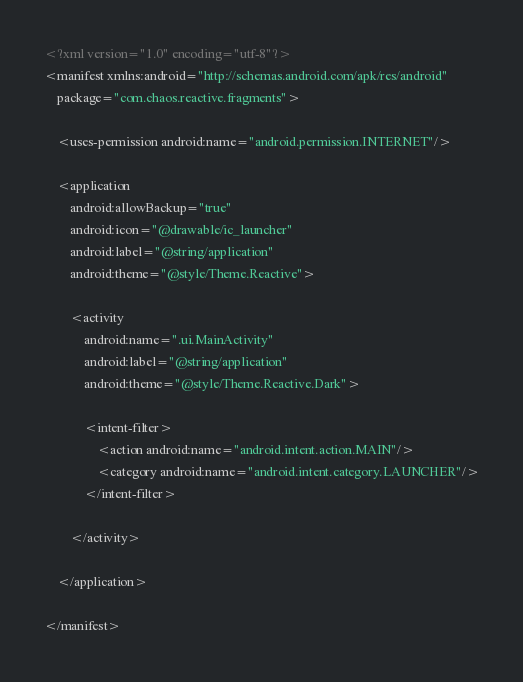<code> <loc_0><loc_0><loc_500><loc_500><_XML_><?xml version="1.0" encoding="utf-8"?>
<manifest xmlns:android="http://schemas.android.com/apk/res/android"
    package="com.chaos.reactive.fragments">

    <uses-permission android:name="android.permission.INTERNET"/>

    <application
        android:allowBackup="true"
        android:icon="@drawable/ic_launcher"
        android:label="@string/application"
        android:theme="@style/Theme.Reactive">

        <activity
            android:name=".ui.MainActivity"
            android:label="@string/application"
            android:theme="@style/Theme.Reactive.Dark">

            <intent-filter>
                <action android:name="android.intent.action.MAIN"/>
                <category android:name="android.intent.category.LAUNCHER"/>
            </intent-filter>

        </activity>

    </application>

</manifest>
</code> 